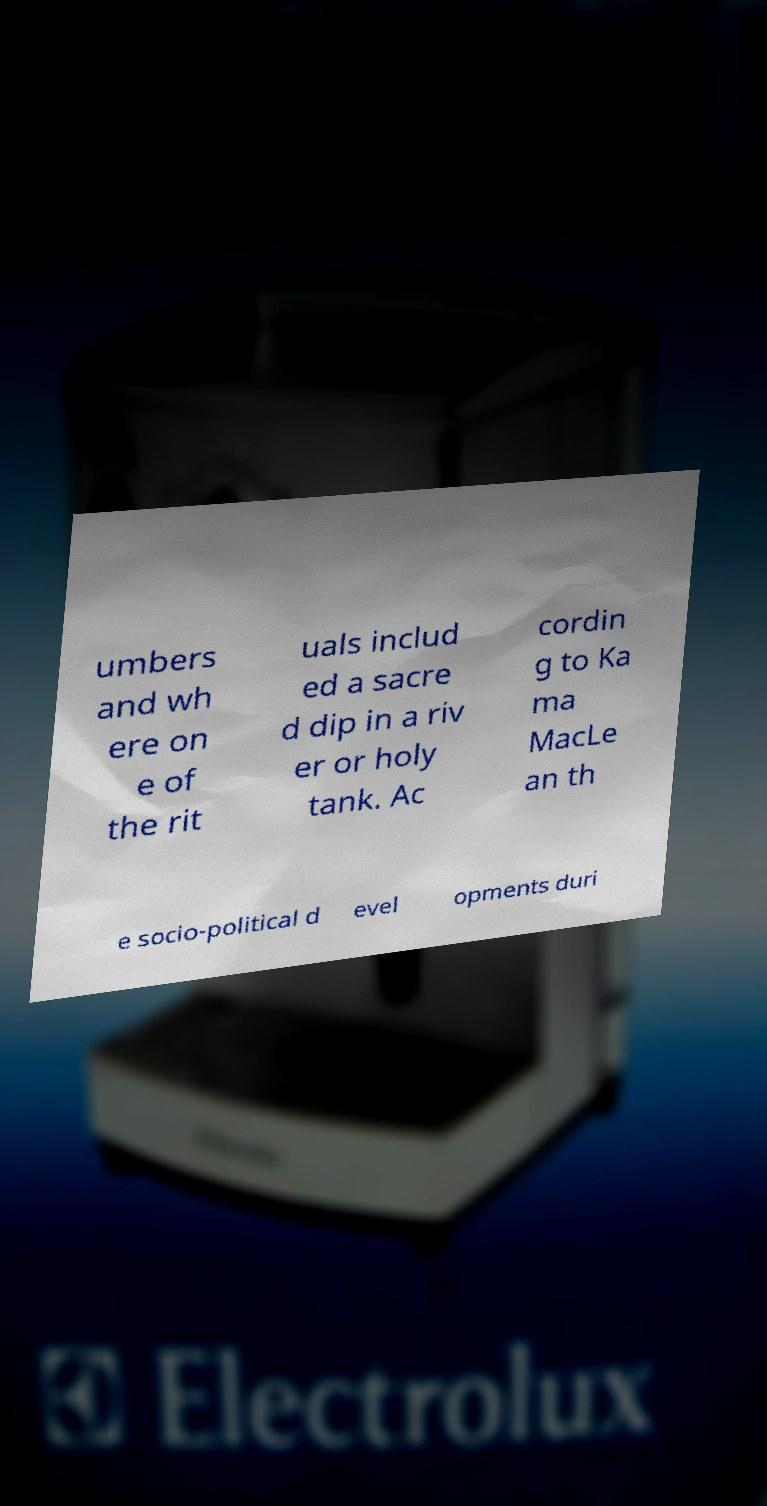Could you assist in decoding the text presented in this image and type it out clearly? umbers and wh ere on e of the rit uals includ ed a sacre d dip in a riv er or holy tank. Ac cordin g to Ka ma MacLe an th e socio-political d evel opments duri 